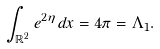<formula> <loc_0><loc_0><loc_500><loc_500>\int _ { { \mathbb { R } } ^ { 2 } } e ^ { 2 \eta } d x = 4 \pi = \Lambda _ { 1 } .</formula> 